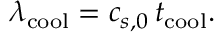Convert formula to latex. <formula><loc_0><loc_0><loc_500><loc_500>\lambda _ { c o o l } = c _ { s , 0 } \, t _ { c o o l } .</formula> 